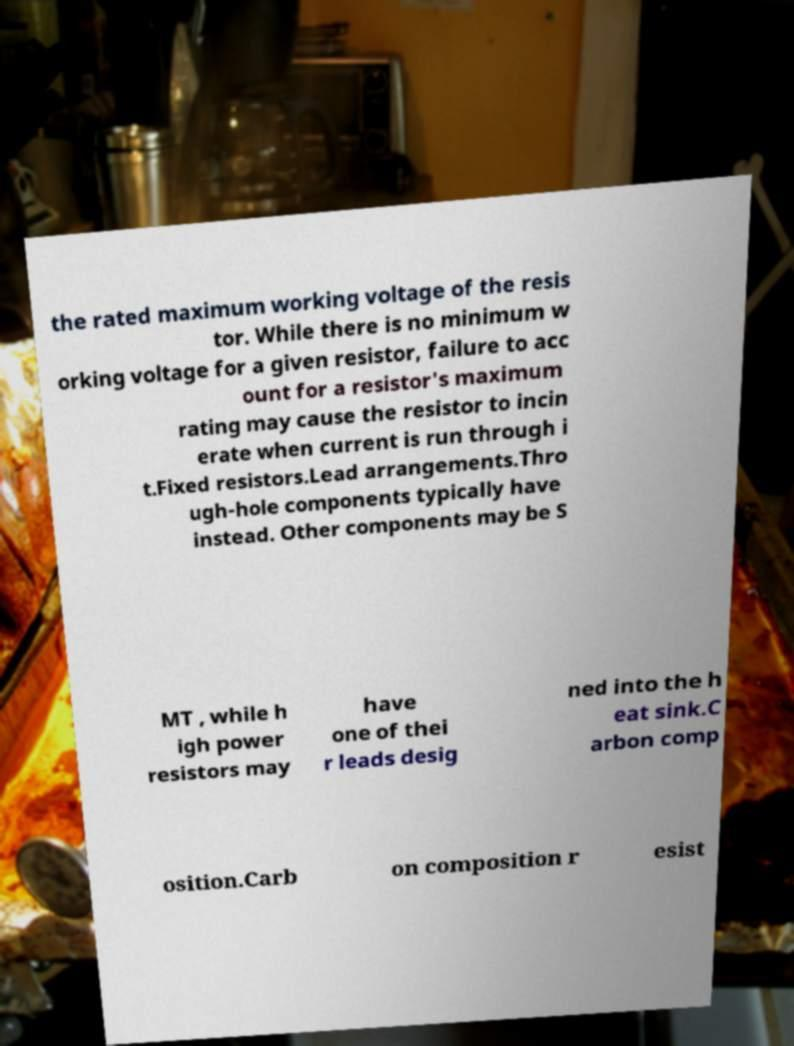For documentation purposes, I need the text within this image transcribed. Could you provide that? the rated maximum working voltage of the resis tor. While there is no minimum w orking voltage for a given resistor, failure to acc ount for a resistor's maximum rating may cause the resistor to incin erate when current is run through i t.Fixed resistors.Lead arrangements.Thro ugh-hole components typically have instead. Other components may be S MT , while h igh power resistors may have one of thei r leads desig ned into the h eat sink.C arbon comp osition.Carb on composition r esist 